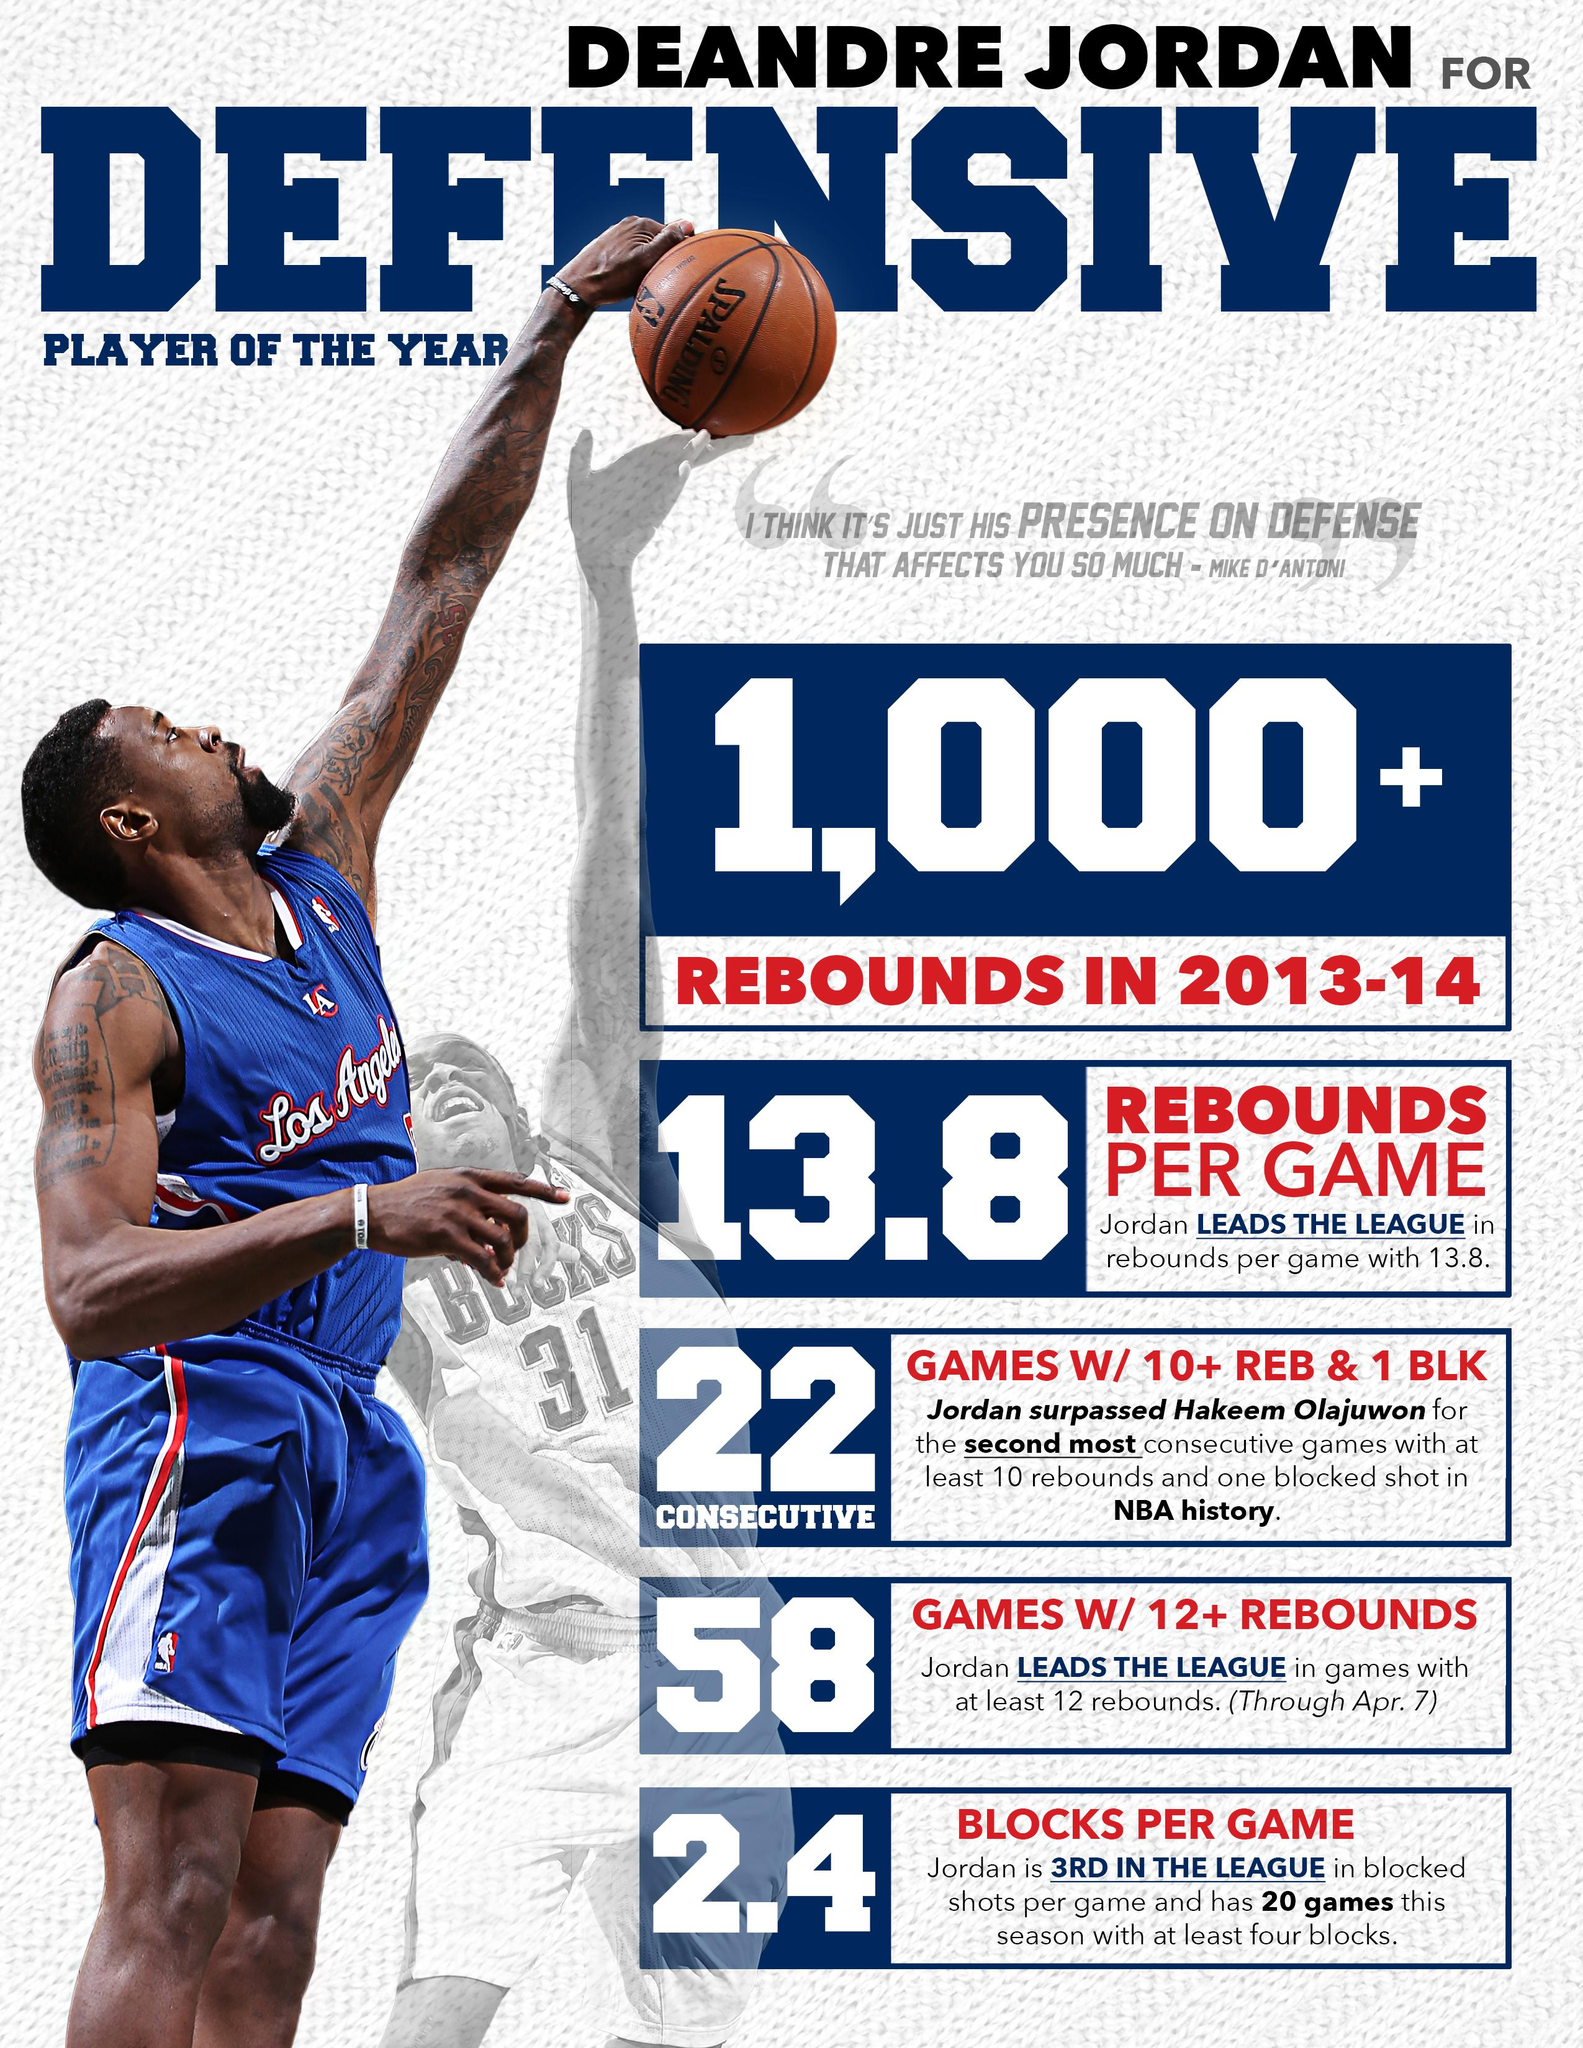Identify some key points in this picture. Deandre Jordan is wearing a blue T-shirt in the infographic. 